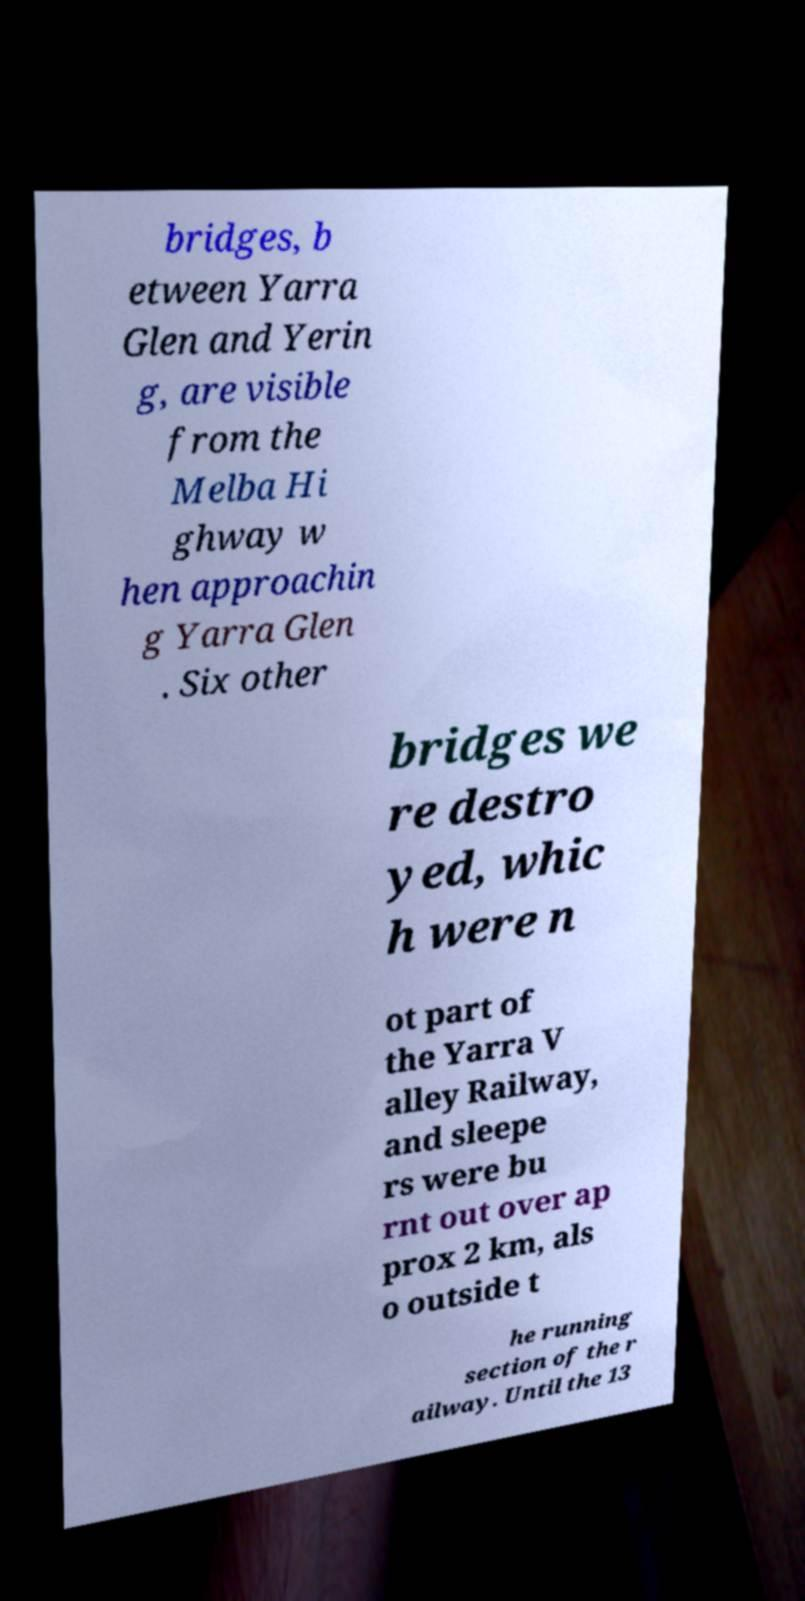There's text embedded in this image that I need extracted. Can you transcribe it verbatim? bridges, b etween Yarra Glen and Yerin g, are visible from the Melba Hi ghway w hen approachin g Yarra Glen . Six other bridges we re destro yed, whic h were n ot part of the Yarra V alley Railway, and sleepe rs were bu rnt out over ap prox 2 km, als o outside t he running section of the r ailway. Until the 13 